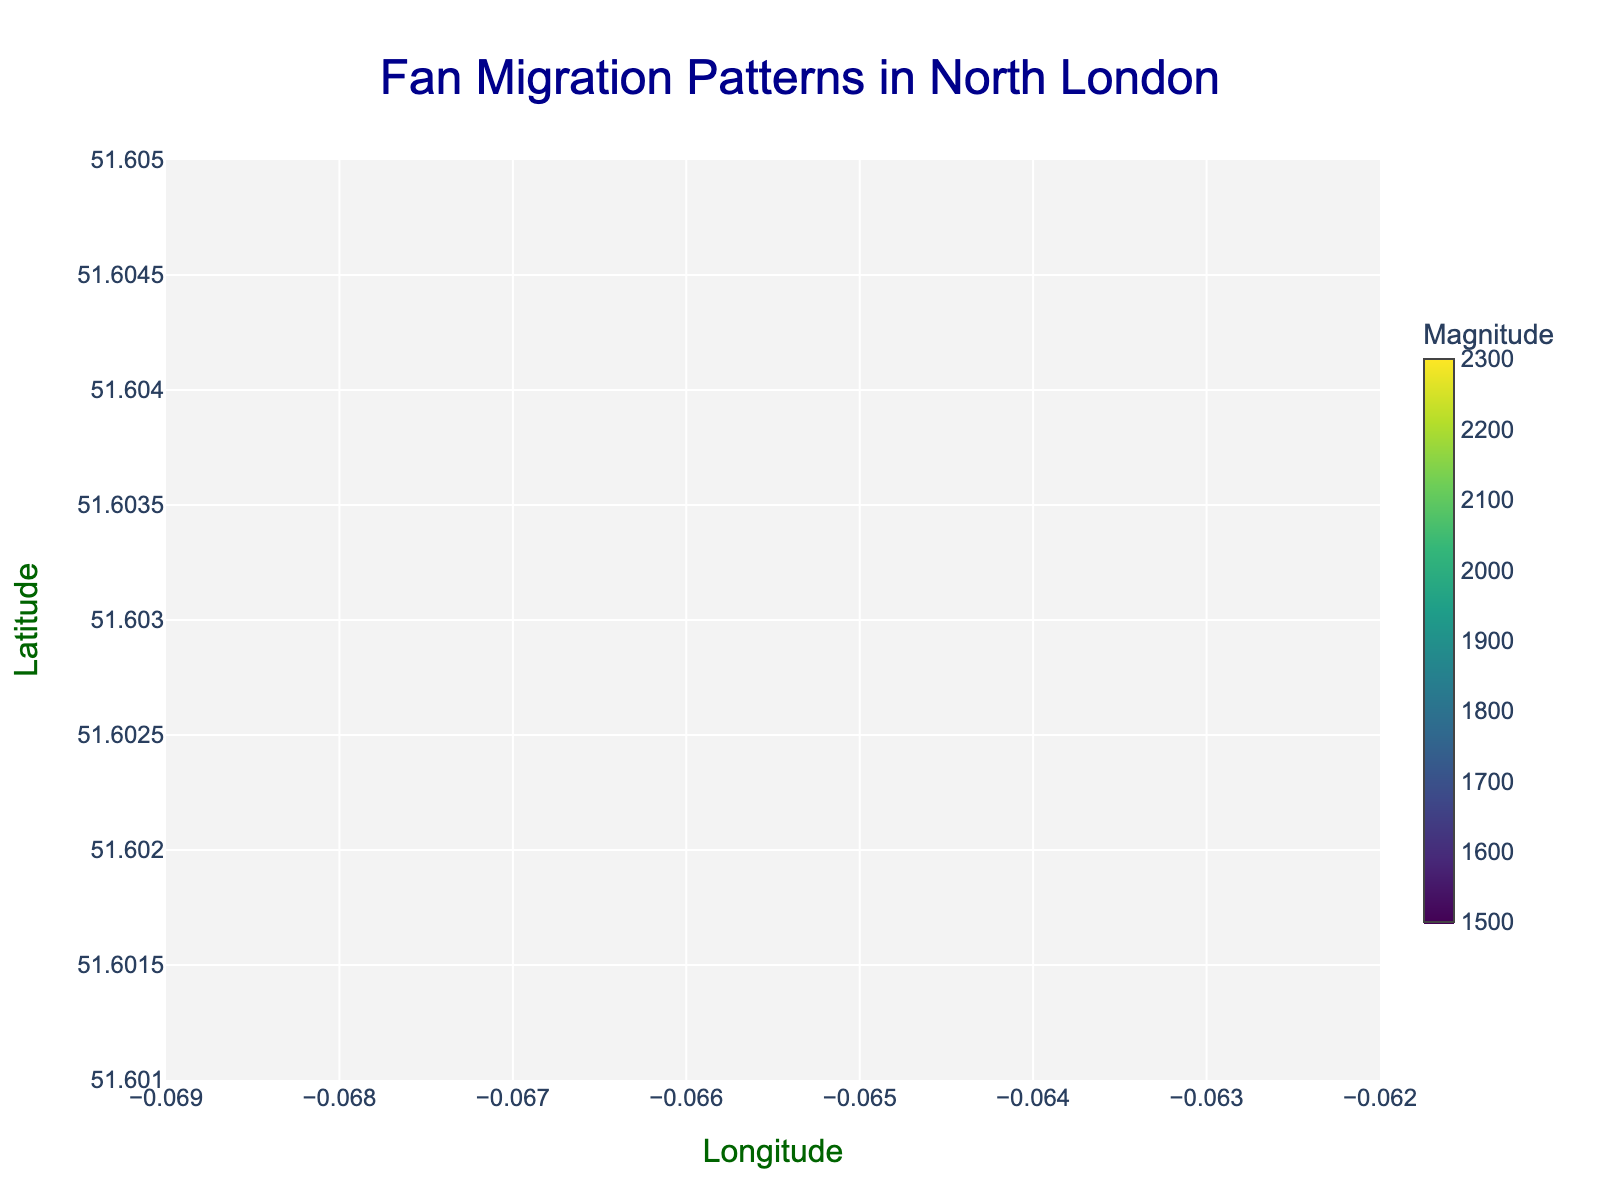What is the title of the plot? The title of the plot is located at the top center of the figure and reads "Fan Migration Patterns in North London".
Answer: Fan Migration Patterns in North London What do the colors of the markers represent? The color of the markers is determined by the "magnitude" data, which is shown by the color scale on the right side of the figure.
Answer: Magnitude How many data points are represented in the plot? By counting the number of markers (points) visible on the plot, you can see that there are 10 data points represented.
Answer: 10 Which data point has the highest magnitude? The data point with the highest magnitude has the brightest color on the Viridis color scale. This is located at coordinates (51.6022, -0.0645) with a magnitude of 2300.
Answer: The point at (51.6022, -0.0645) with a magnitude of 2300 Which data point shows a movement directed towards the northwest? A northwest direction implies a negative x-component and a positive y-component in the arrow. The point at (51.6032, -0.0657) has a movement vector of (-0.2, 0.3), indicating a movement towards the northwest.
Answer: The point at (51.6032, -0.0657) What is the average magnitude of all data points? To find the average magnitude, sum all the magnitudes (1500 + 2000 + 1800 + 2200 + 1700 + 1900 + 2100 + 1600 + 2300 + 1800) = 18900, then divide by the number of data points, which is 10. Average = 18900 / 10 = 1890.
Answer: 1890 Which data points indicate fan movements directly towards the stadium? Movements directed towards the stadium can be inferred from the length and direction of arrows converging. Data points with (0.5, 0.3) at (51.6022, -0.0645) and other arrows with vectors indicating similar directional orientations might represent this.
Answer: Not clearly specified without further context Compare the magnitude of fan movement at (51.6041, -0.0673) with that at (51.6038, -0.0665). Which is greater? The magnitude at (51.6041, -0.0673) is 2200, whereas at (51.6038, -0.0665), it is 2000. Therefore, the former is greater.
Answer: 2200 (at 51.6041, -0.0673) Which point shows a strong northeastward movement? Northeastward movement implies a positive x and y component in the arrow vector. The point at (51.6025, -0.0649) with a vector (0.3, 0.2) indicates this direction.
Answer: The point at (51.6025, -0.0649) What are the coordinates of the point with the lowest magnitude? The lowest magnitude is indicated by the darkest color scale. The point at (51.6032, -0.0657) holds the lowest magnitude of 1500.
Answer: (51.6032, -0.0657) 